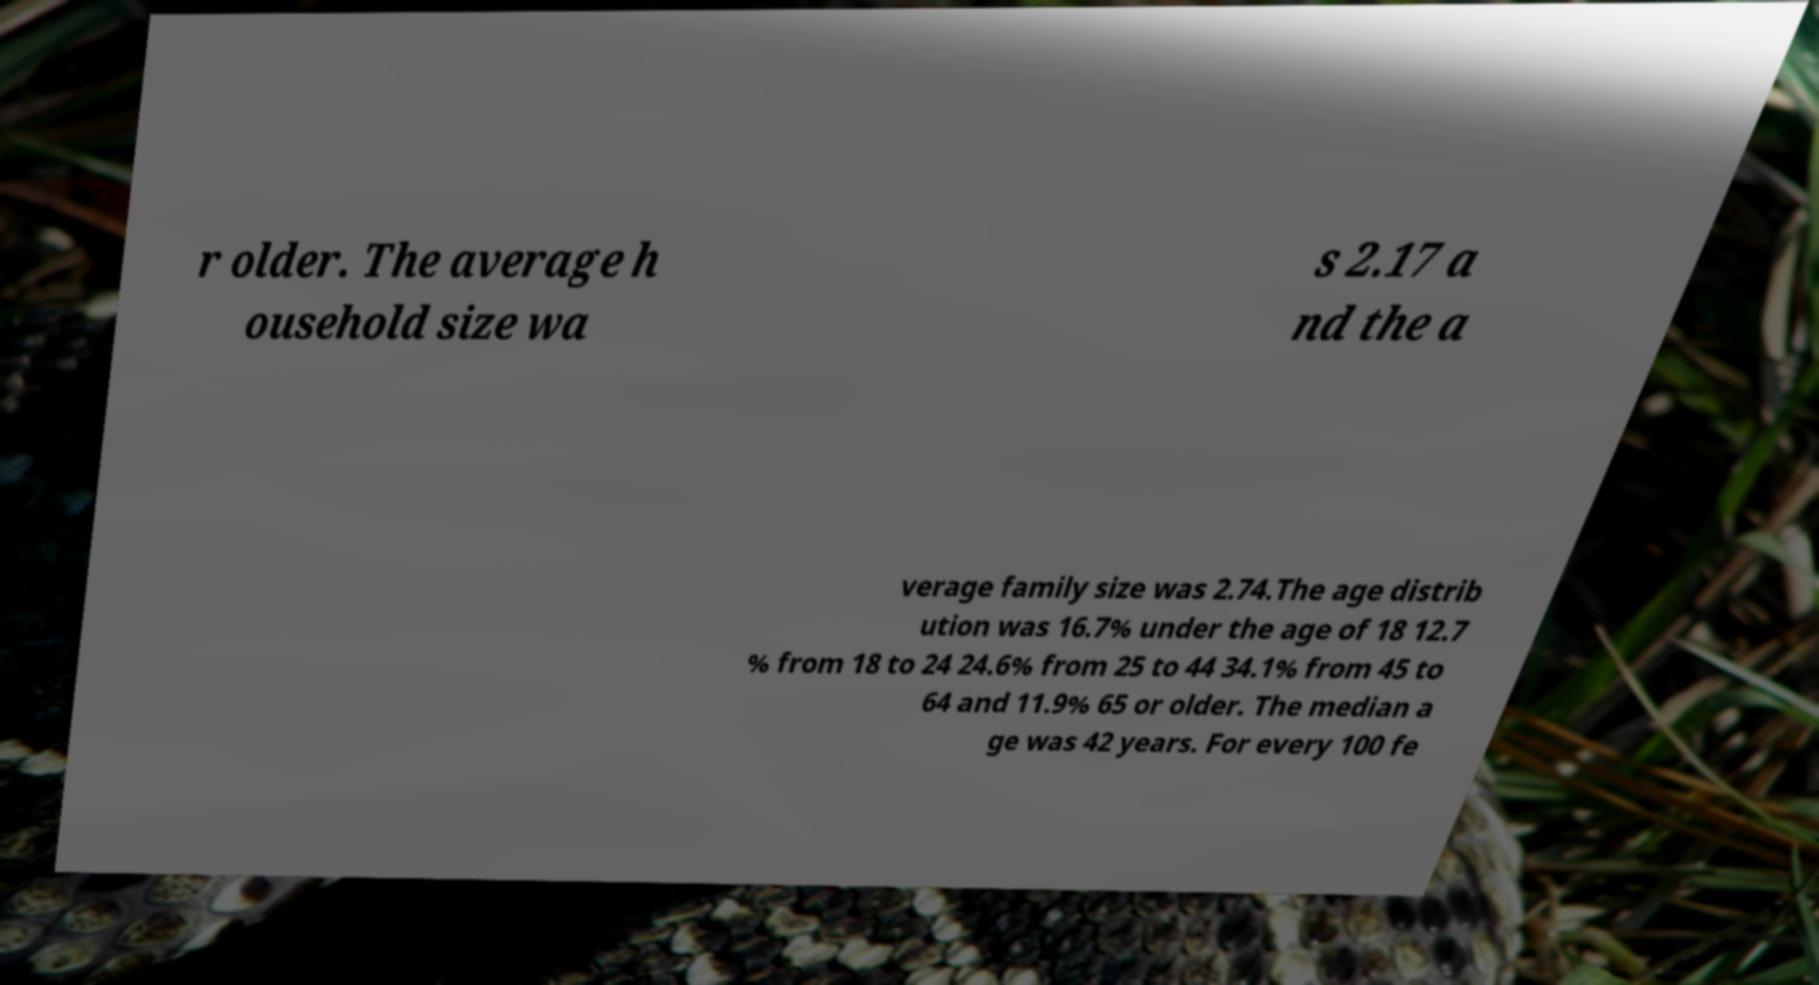Can you read and provide the text displayed in the image?This photo seems to have some interesting text. Can you extract and type it out for me? r older. The average h ousehold size wa s 2.17 a nd the a verage family size was 2.74.The age distrib ution was 16.7% under the age of 18 12.7 % from 18 to 24 24.6% from 25 to 44 34.1% from 45 to 64 and 11.9% 65 or older. The median a ge was 42 years. For every 100 fe 